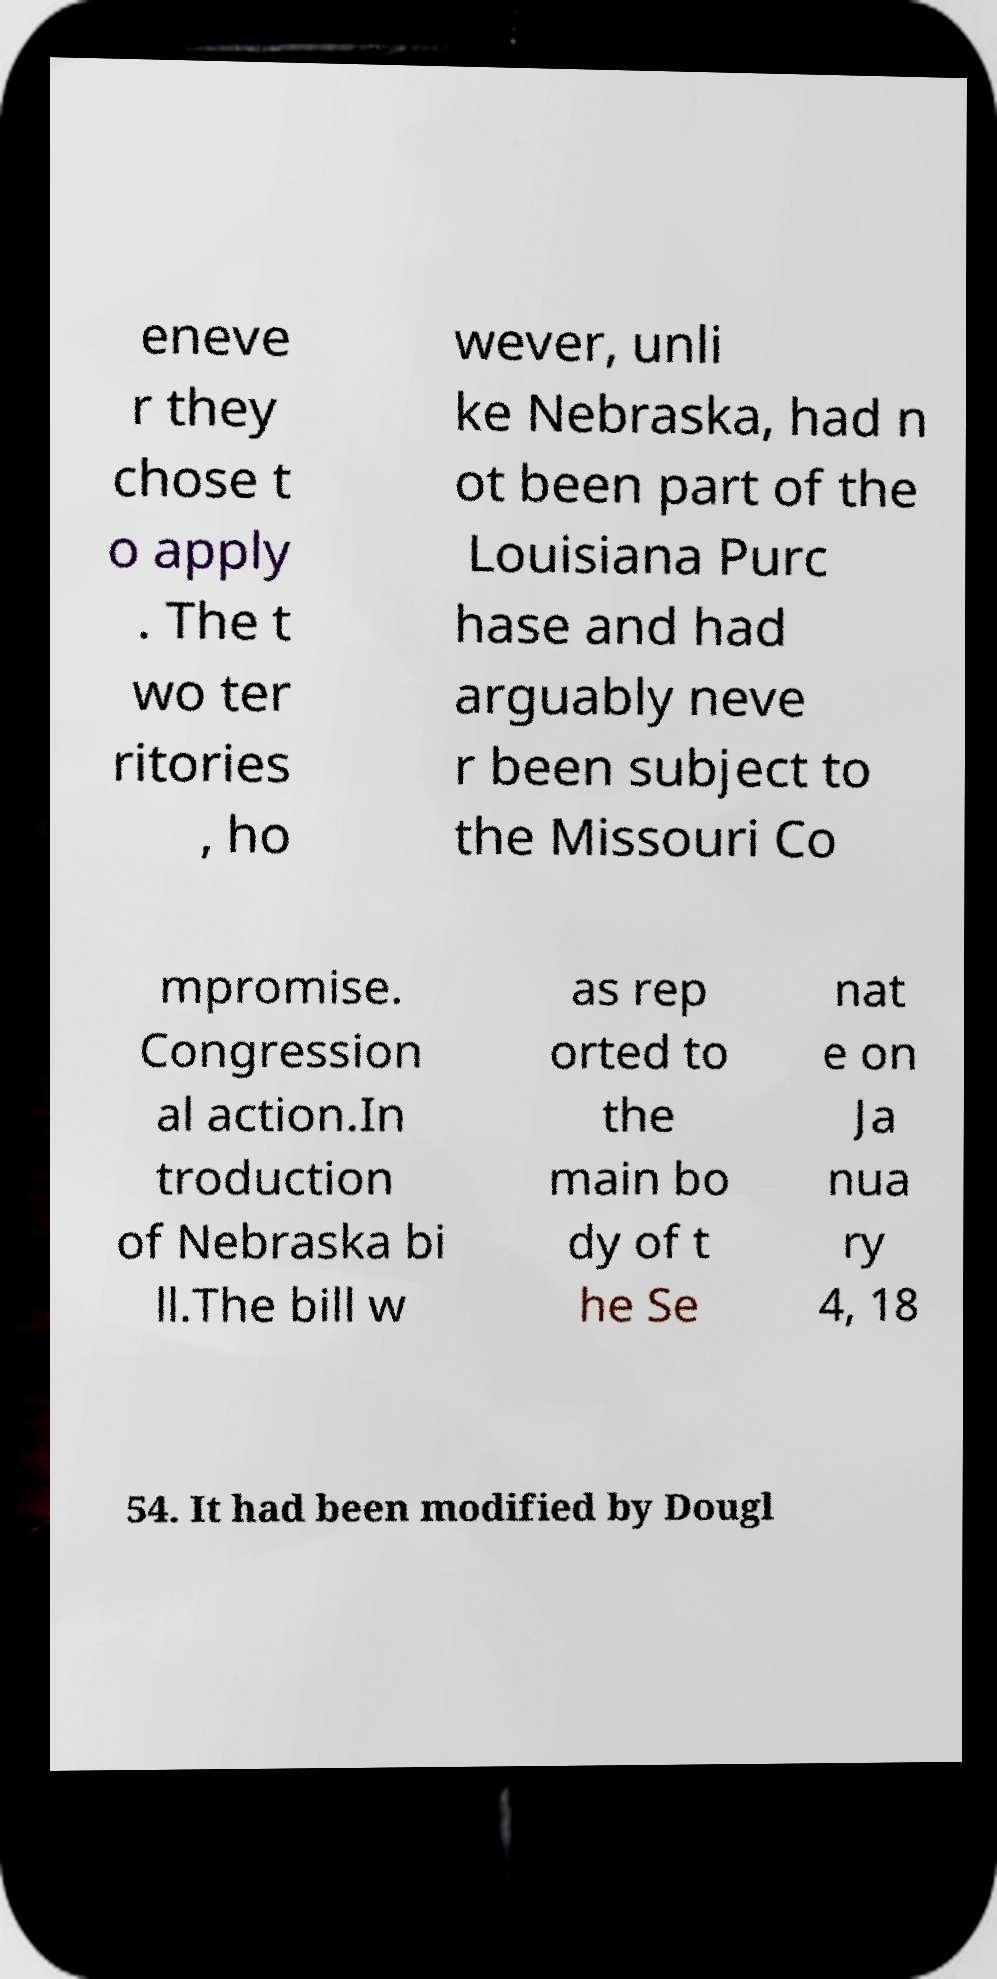There's text embedded in this image that I need extracted. Can you transcribe it verbatim? eneve r they chose t o apply . The t wo ter ritories , ho wever, unli ke Nebraska, had n ot been part of the Louisiana Purc hase and had arguably neve r been subject to the Missouri Co mpromise. Congression al action.In troduction of Nebraska bi ll.The bill w as rep orted to the main bo dy of t he Se nat e on Ja nua ry 4, 18 54. It had been modified by Dougl 